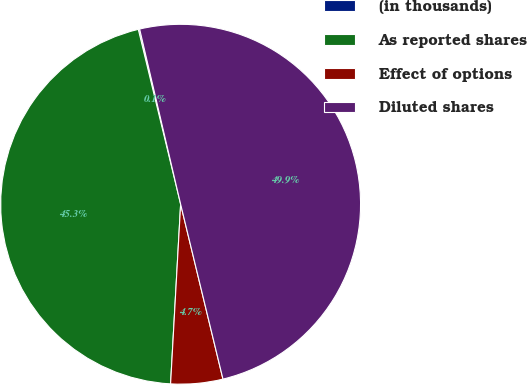Convert chart. <chart><loc_0><loc_0><loc_500><loc_500><pie_chart><fcel>(in thousands)<fcel>As reported shares<fcel>Effect of options<fcel>Diluted shares<nl><fcel>0.12%<fcel>45.33%<fcel>4.67%<fcel>49.88%<nl></chart> 